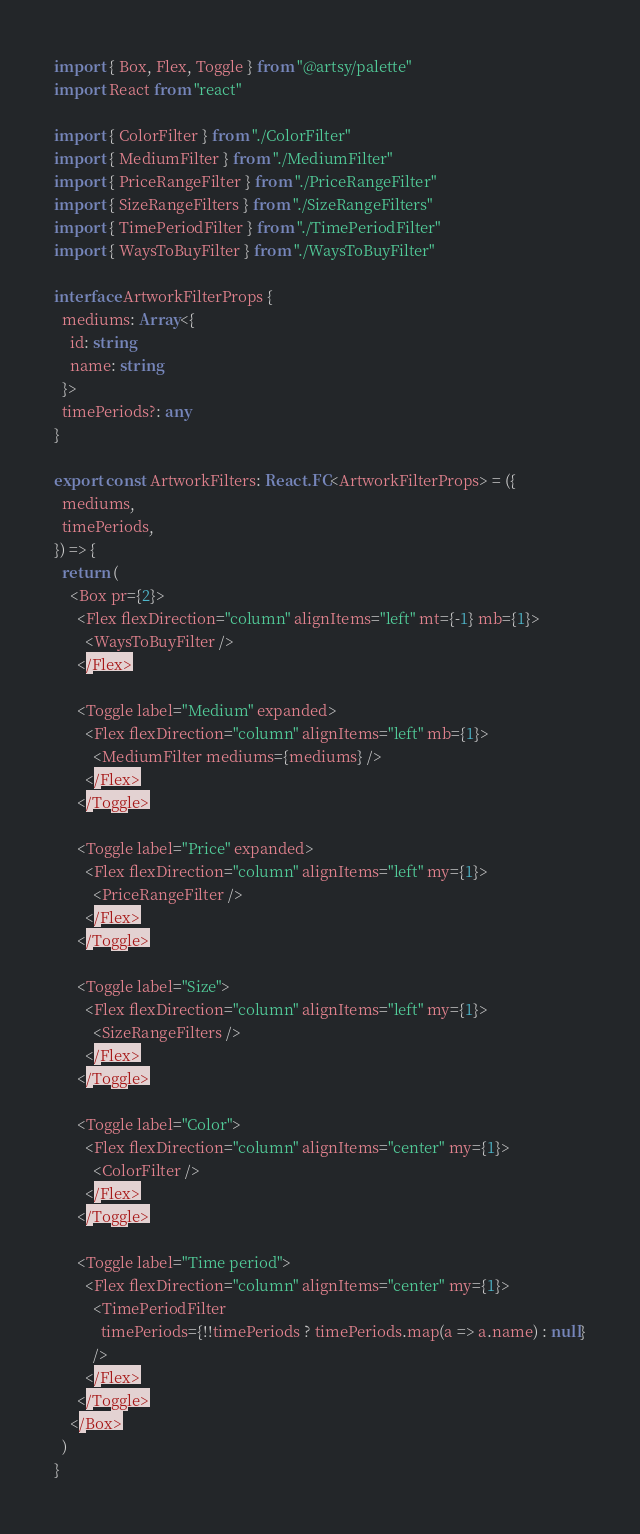Convert code to text. <code><loc_0><loc_0><loc_500><loc_500><_TypeScript_>import { Box, Flex, Toggle } from "@artsy/palette"
import React from "react"

import { ColorFilter } from "./ColorFilter"
import { MediumFilter } from "./MediumFilter"
import { PriceRangeFilter } from "./PriceRangeFilter"
import { SizeRangeFilters } from "./SizeRangeFilters"
import { TimePeriodFilter } from "./TimePeriodFilter"
import { WaysToBuyFilter } from "./WaysToBuyFilter"

interface ArtworkFilterProps {
  mediums: Array<{
    id: string
    name: string
  }>
  timePeriods?: any
}

export const ArtworkFilters: React.FC<ArtworkFilterProps> = ({
  mediums,
  timePeriods,
}) => {
  return (
    <Box pr={2}>
      <Flex flexDirection="column" alignItems="left" mt={-1} mb={1}>
        <WaysToBuyFilter />
      </Flex>

      <Toggle label="Medium" expanded>
        <Flex flexDirection="column" alignItems="left" mb={1}>
          <MediumFilter mediums={mediums} />
        </Flex>
      </Toggle>

      <Toggle label="Price" expanded>
        <Flex flexDirection="column" alignItems="left" my={1}>
          <PriceRangeFilter />
        </Flex>
      </Toggle>

      <Toggle label="Size">
        <Flex flexDirection="column" alignItems="left" my={1}>
          <SizeRangeFilters />
        </Flex>
      </Toggle>

      <Toggle label="Color">
        <Flex flexDirection="column" alignItems="center" my={1}>
          <ColorFilter />
        </Flex>
      </Toggle>

      <Toggle label="Time period">
        <Flex flexDirection="column" alignItems="center" my={1}>
          <TimePeriodFilter
            timePeriods={!!timePeriods ? timePeriods.map(a => a.name) : null}
          />
        </Flex>
      </Toggle>
    </Box>
  )
}
</code> 